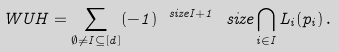<formula> <loc_0><loc_0><loc_500><loc_500>\ W U H = \sum _ { \emptyset \neq I \subseteq [ d ] } ( - 1 ) ^ { \ s i z e { I } + 1 } \ s i z e { \bigcap _ { i \in I } L _ { i } ( p _ { i } ) } \, .</formula> 